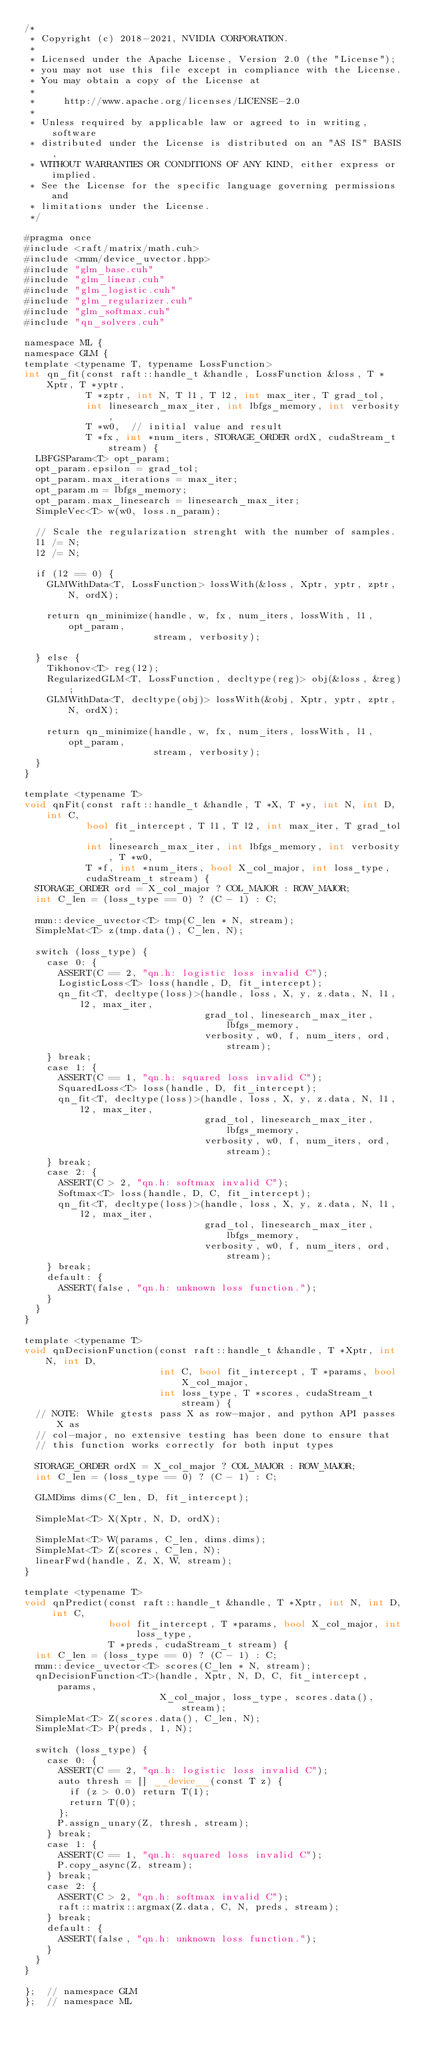Convert code to text. <code><loc_0><loc_0><loc_500><loc_500><_Cuda_>/*
 * Copyright (c) 2018-2021, NVIDIA CORPORATION.
 *
 * Licensed under the Apache License, Version 2.0 (the "License");
 * you may not use this file except in compliance with the License.
 * You may obtain a copy of the License at
 *
 *     http://www.apache.org/licenses/LICENSE-2.0
 *
 * Unless required by applicable law or agreed to in writing, software
 * distributed under the License is distributed on an "AS IS" BASIS,
 * WITHOUT WARRANTIES OR CONDITIONS OF ANY KIND, either express or implied.
 * See the License for the specific language governing permissions and
 * limitations under the License.
 */

#pragma once
#include <raft/matrix/math.cuh>
#include <rmm/device_uvector.hpp>
#include "glm_base.cuh"
#include "glm_linear.cuh"
#include "glm_logistic.cuh"
#include "glm_regularizer.cuh"
#include "glm_softmax.cuh"
#include "qn_solvers.cuh"

namespace ML {
namespace GLM {
template <typename T, typename LossFunction>
int qn_fit(const raft::handle_t &handle, LossFunction &loss, T *Xptr, T *yptr,
           T *zptr, int N, T l1, T l2, int max_iter, T grad_tol,
           int linesearch_max_iter, int lbfgs_memory, int verbosity,
           T *w0,  // initial value and result
           T *fx, int *num_iters, STORAGE_ORDER ordX, cudaStream_t stream) {
  LBFGSParam<T> opt_param;
  opt_param.epsilon = grad_tol;
  opt_param.max_iterations = max_iter;
  opt_param.m = lbfgs_memory;
  opt_param.max_linesearch = linesearch_max_iter;
  SimpleVec<T> w(w0, loss.n_param);

  // Scale the regularization strenght with the number of samples.
  l1 /= N;
  l2 /= N;

  if (l2 == 0) {
    GLMWithData<T, LossFunction> lossWith(&loss, Xptr, yptr, zptr, N, ordX);

    return qn_minimize(handle, w, fx, num_iters, lossWith, l1, opt_param,
                       stream, verbosity);

  } else {
    Tikhonov<T> reg(l2);
    RegularizedGLM<T, LossFunction, decltype(reg)> obj(&loss, &reg);
    GLMWithData<T, decltype(obj)> lossWith(&obj, Xptr, yptr, zptr, N, ordX);

    return qn_minimize(handle, w, fx, num_iters, lossWith, l1, opt_param,
                       stream, verbosity);
  }
}

template <typename T>
void qnFit(const raft::handle_t &handle, T *X, T *y, int N, int D, int C,
           bool fit_intercept, T l1, T l2, int max_iter, T grad_tol,
           int linesearch_max_iter, int lbfgs_memory, int verbosity, T *w0,
           T *f, int *num_iters, bool X_col_major, int loss_type,
           cudaStream_t stream) {
  STORAGE_ORDER ord = X_col_major ? COL_MAJOR : ROW_MAJOR;
  int C_len = (loss_type == 0) ? (C - 1) : C;

  rmm::device_uvector<T> tmp(C_len * N, stream);
  SimpleMat<T> z(tmp.data(), C_len, N);

  switch (loss_type) {
    case 0: {
      ASSERT(C == 2, "qn.h: logistic loss invalid C");
      LogisticLoss<T> loss(handle, D, fit_intercept);
      qn_fit<T, decltype(loss)>(handle, loss, X, y, z.data, N, l1, l2, max_iter,
                                grad_tol, linesearch_max_iter, lbfgs_memory,
                                verbosity, w0, f, num_iters, ord, stream);
    } break;
    case 1: {
      ASSERT(C == 1, "qn.h: squared loss invalid C");
      SquaredLoss<T> loss(handle, D, fit_intercept);
      qn_fit<T, decltype(loss)>(handle, loss, X, y, z.data, N, l1, l2, max_iter,
                                grad_tol, linesearch_max_iter, lbfgs_memory,
                                verbosity, w0, f, num_iters, ord, stream);
    } break;
    case 2: {
      ASSERT(C > 2, "qn.h: softmax invalid C");
      Softmax<T> loss(handle, D, C, fit_intercept);
      qn_fit<T, decltype(loss)>(handle, loss, X, y, z.data, N, l1, l2, max_iter,
                                grad_tol, linesearch_max_iter, lbfgs_memory,
                                verbosity, w0, f, num_iters, ord, stream);
    } break;
    default: {
      ASSERT(false, "qn.h: unknown loss function.");
    }
  }
}

template <typename T>
void qnDecisionFunction(const raft::handle_t &handle, T *Xptr, int N, int D,
                        int C, bool fit_intercept, T *params, bool X_col_major,
                        int loss_type, T *scores, cudaStream_t stream) {
  // NOTE: While gtests pass X as row-major, and python API passes X as
  // col-major, no extensive testing has been done to ensure that
  // this function works correctly for both input types

  STORAGE_ORDER ordX = X_col_major ? COL_MAJOR : ROW_MAJOR;
  int C_len = (loss_type == 0) ? (C - 1) : C;

  GLMDims dims(C_len, D, fit_intercept);

  SimpleMat<T> X(Xptr, N, D, ordX);

  SimpleMat<T> W(params, C_len, dims.dims);
  SimpleMat<T> Z(scores, C_len, N);
  linearFwd(handle, Z, X, W, stream);
}

template <typename T>
void qnPredict(const raft::handle_t &handle, T *Xptr, int N, int D, int C,
               bool fit_intercept, T *params, bool X_col_major, int loss_type,
               T *preds, cudaStream_t stream) {
  int C_len = (loss_type == 0) ? (C - 1) : C;
  rmm::device_uvector<T> scores(C_len * N, stream);
  qnDecisionFunction<T>(handle, Xptr, N, D, C, fit_intercept, params,
                        X_col_major, loss_type, scores.data(), stream);
  SimpleMat<T> Z(scores.data(), C_len, N);
  SimpleMat<T> P(preds, 1, N);

  switch (loss_type) {
    case 0: {
      ASSERT(C == 2, "qn.h: logistic loss invalid C");
      auto thresh = [] __device__(const T z) {
        if (z > 0.0) return T(1);
        return T(0);
      };
      P.assign_unary(Z, thresh, stream);
    } break;
    case 1: {
      ASSERT(C == 1, "qn.h: squared loss invalid C");
      P.copy_async(Z, stream);
    } break;
    case 2: {
      ASSERT(C > 2, "qn.h: softmax invalid C");
      raft::matrix::argmax(Z.data, C, N, preds, stream);
    } break;
    default: {
      ASSERT(false, "qn.h: unknown loss function.");
    }
  }
}

};  // namespace GLM
};  // namespace ML
</code> 